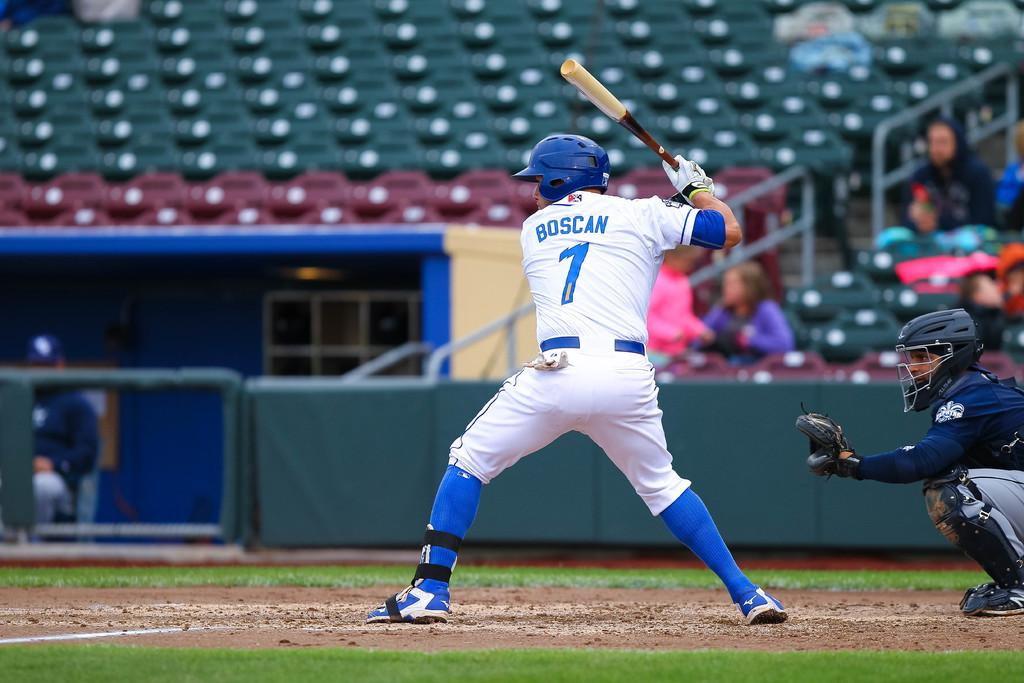<image>
Summarize the visual content of the image. A baseball player in a blue and white uniform with the number one on his back is about to swing his bat. 